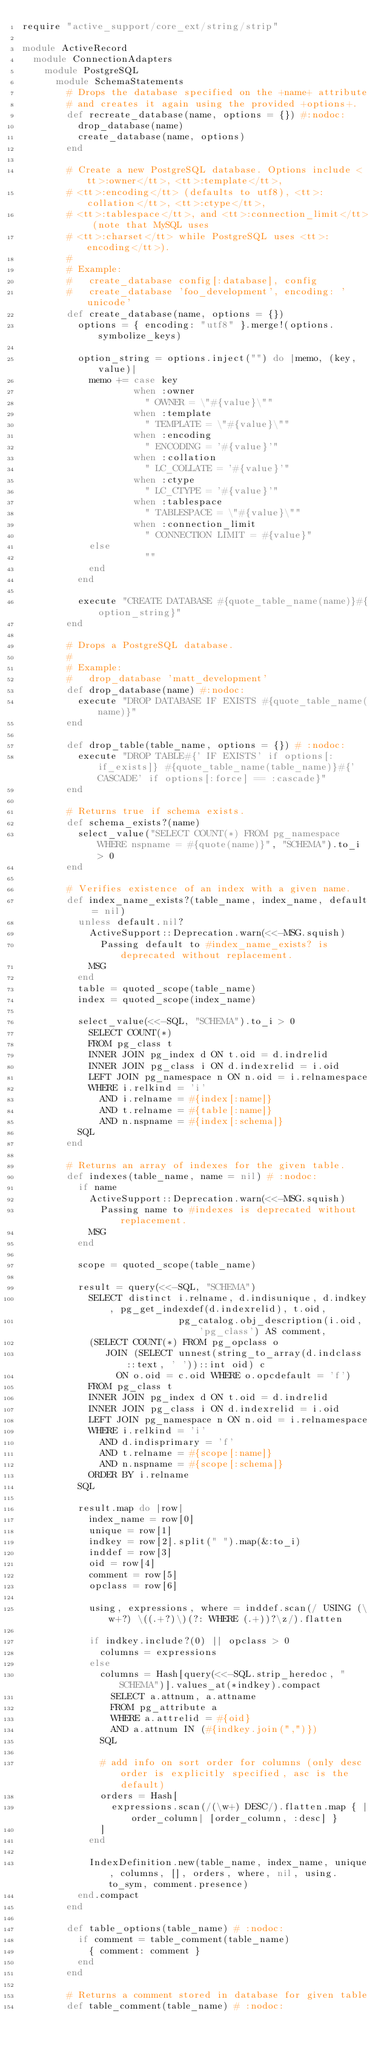<code> <loc_0><loc_0><loc_500><loc_500><_Ruby_>require "active_support/core_ext/string/strip"

module ActiveRecord
  module ConnectionAdapters
    module PostgreSQL
      module SchemaStatements
        # Drops the database specified on the +name+ attribute
        # and creates it again using the provided +options+.
        def recreate_database(name, options = {}) #:nodoc:
          drop_database(name)
          create_database(name, options)
        end

        # Create a new PostgreSQL database. Options include <tt>:owner</tt>, <tt>:template</tt>,
        # <tt>:encoding</tt> (defaults to utf8), <tt>:collation</tt>, <tt>:ctype</tt>,
        # <tt>:tablespace</tt>, and <tt>:connection_limit</tt> (note that MySQL uses
        # <tt>:charset</tt> while PostgreSQL uses <tt>:encoding</tt>).
        #
        # Example:
        #   create_database config[:database], config
        #   create_database 'foo_development', encoding: 'unicode'
        def create_database(name, options = {})
          options = { encoding: "utf8" }.merge!(options.symbolize_keys)

          option_string = options.inject("") do |memo, (key, value)|
            memo += case key
                    when :owner
                      " OWNER = \"#{value}\""
                    when :template
                      " TEMPLATE = \"#{value}\""
                    when :encoding
                      " ENCODING = '#{value}'"
                    when :collation
                      " LC_COLLATE = '#{value}'"
                    when :ctype
                      " LC_CTYPE = '#{value}'"
                    when :tablespace
                      " TABLESPACE = \"#{value}\""
                    when :connection_limit
                      " CONNECTION LIMIT = #{value}"
            else
                      ""
            end
          end

          execute "CREATE DATABASE #{quote_table_name(name)}#{option_string}"
        end

        # Drops a PostgreSQL database.
        #
        # Example:
        #   drop_database 'matt_development'
        def drop_database(name) #:nodoc:
          execute "DROP DATABASE IF EXISTS #{quote_table_name(name)}"
        end

        def drop_table(table_name, options = {}) # :nodoc:
          execute "DROP TABLE#{' IF EXISTS' if options[:if_exists]} #{quote_table_name(table_name)}#{' CASCADE' if options[:force] == :cascade}"
        end

        # Returns true if schema exists.
        def schema_exists?(name)
          select_value("SELECT COUNT(*) FROM pg_namespace WHERE nspname = #{quote(name)}", "SCHEMA").to_i > 0
        end

        # Verifies existence of an index with a given name.
        def index_name_exists?(table_name, index_name, default = nil)
          unless default.nil?
            ActiveSupport::Deprecation.warn(<<-MSG.squish)
              Passing default to #index_name_exists? is deprecated without replacement.
            MSG
          end
          table = quoted_scope(table_name)
          index = quoted_scope(index_name)

          select_value(<<-SQL, "SCHEMA").to_i > 0
            SELECT COUNT(*)
            FROM pg_class t
            INNER JOIN pg_index d ON t.oid = d.indrelid
            INNER JOIN pg_class i ON d.indexrelid = i.oid
            LEFT JOIN pg_namespace n ON n.oid = i.relnamespace
            WHERE i.relkind = 'i'
              AND i.relname = #{index[:name]}
              AND t.relname = #{table[:name]}
              AND n.nspname = #{index[:schema]}
          SQL
        end

        # Returns an array of indexes for the given table.
        def indexes(table_name, name = nil) # :nodoc:
          if name
            ActiveSupport::Deprecation.warn(<<-MSG.squish)
              Passing name to #indexes is deprecated without replacement.
            MSG
          end

          scope = quoted_scope(table_name)

          result = query(<<-SQL, "SCHEMA")
            SELECT distinct i.relname, d.indisunique, d.indkey, pg_get_indexdef(d.indexrelid), t.oid,
                            pg_catalog.obj_description(i.oid, 'pg_class') AS comment,
            (SELECT COUNT(*) FROM pg_opclass o
               JOIN (SELECT unnest(string_to_array(d.indclass::text, ' '))::int oid) c
                 ON o.oid = c.oid WHERE o.opcdefault = 'f')
            FROM pg_class t
            INNER JOIN pg_index d ON t.oid = d.indrelid
            INNER JOIN pg_class i ON d.indexrelid = i.oid
            LEFT JOIN pg_namespace n ON n.oid = i.relnamespace
            WHERE i.relkind = 'i'
              AND d.indisprimary = 'f'
              AND t.relname = #{scope[:name]}
              AND n.nspname = #{scope[:schema]}
            ORDER BY i.relname
          SQL

          result.map do |row|
            index_name = row[0]
            unique = row[1]
            indkey = row[2].split(" ").map(&:to_i)
            inddef = row[3]
            oid = row[4]
            comment = row[5]
            opclass = row[6]

            using, expressions, where = inddef.scan(/ USING (\w+?) \((.+?)\)(?: WHERE (.+))?\z/).flatten

            if indkey.include?(0) || opclass > 0
              columns = expressions
            else
              columns = Hash[query(<<-SQL.strip_heredoc, "SCHEMA")].values_at(*indkey).compact
                SELECT a.attnum, a.attname
                FROM pg_attribute a
                WHERE a.attrelid = #{oid}
                AND a.attnum IN (#{indkey.join(",")})
              SQL

              # add info on sort order for columns (only desc order is explicitly specified, asc is the default)
              orders = Hash[
                expressions.scan(/(\w+) DESC/).flatten.map { |order_column| [order_column, :desc] }
              ]
            end

            IndexDefinition.new(table_name, index_name, unique, columns, [], orders, where, nil, using.to_sym, comment.presence)
          end.compact
        end

        def table_options(table_name) # :nodoc:
          if comment = table_comment(table_name)
            { comment: comment }
          end
        end

        # Returns a comment stored in database for given table
        def table_comment(table_name) # :nodoc:</code> 